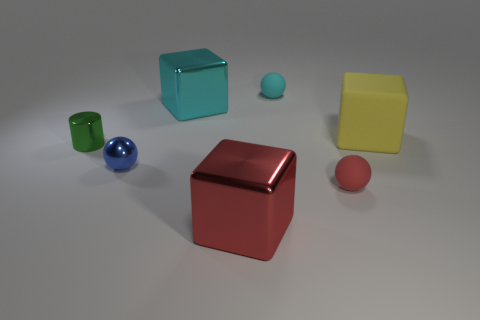Subtract all yellow blocks. How many blocks are left? 2 Subtract all small shiny balls. How many balls are left? 2 Subtract 2 blocks. How many blocks are left? 1 Add 5 small red balls. How many small red balls exist? 6 Add 3 large cyan blocks. How many objects exist? 10 Subtract 0 green spheres. How many objects are left? 7 Subtract all spheres. How many objects are left? 4 Subtract all cyan cylinders. Subtract all brown cubes. How many cylinders are left? 1 Subtract all cyan spheres. How many yellow blocks are left? 1 Subtract all large red metallic blocks. Subtract all large yellow matte things. How many objects are left? 5 